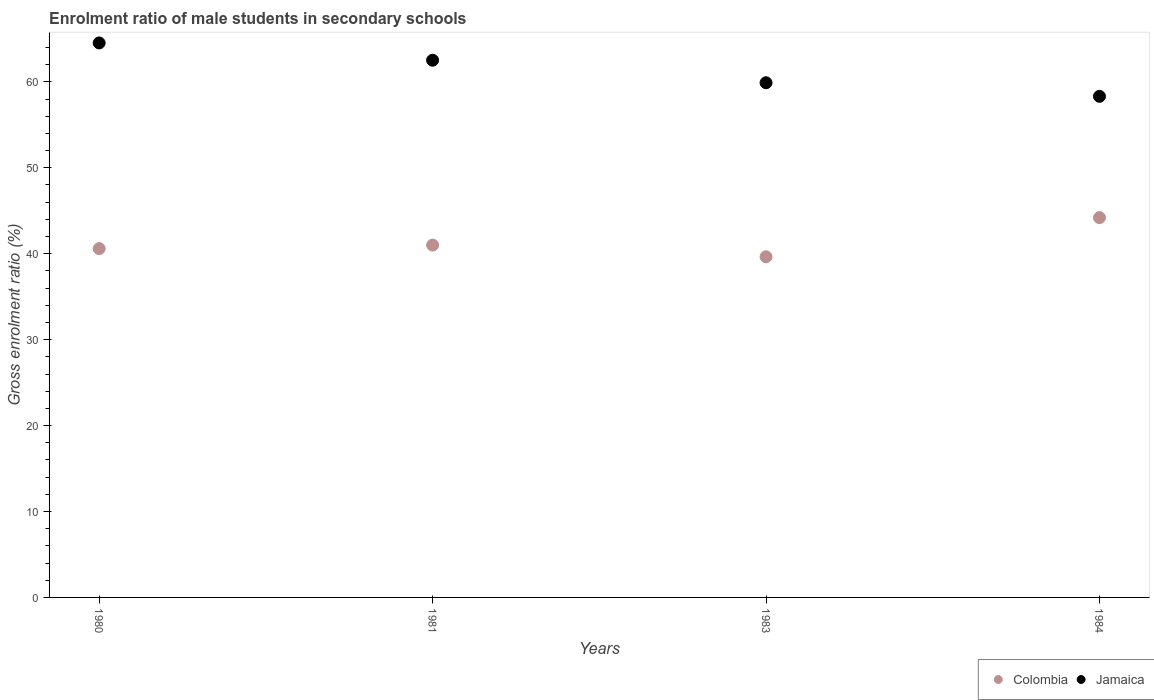How many different coloured dotlines are there?
Offer a very short reply. 2. What is the enrolment ratio of male students in secondary schools in Jamaica in 1981?
Give a very brief answer. 62.52. Across all years, what is the maximum enrolment ratio of male students in secondary schools in Colombia?
Your response must be concise. 44.2. Across all years, what is the minimum enrolment ratio of male students in secondary schools in Jamaica?
Your response must be concise. 58.32. In which year was the enrolment ratio of male students in secondary schools in Colombia maximum?
Ensure brevity in your answer.  1984. In which year was the enrolment ratio of male students in secondary schools in Jamaica minimum?
Make the answer very short. 1984. What is the total enrolment ratio of male students in secondary schools in Colombia in the graph?
Provide a short and direct response. 165.45. What is the difference between the enrolment ratio of male students in secondary schools in Jamaica in 1981 and that in 1984?
Provide a succinct answer. 4.2. What is the difference between the enrolment ratio of male students in secondary schools in Colombia in 1983 and the enrolment ratio of male students in secondary schools in Jamaica in 1981?
Your answer should be very brief. -22.87. What is the average enrolment ratio of male students in secondary schools in Colombia per year?
Offer a very short reply. 41.36. In the year 1981, what is the difference between the enrolment ratio of male students in secondary schools in Colombia and enrolment ratio of male students in secondary schools in Jamaica?
Offer a terse response. -21.51. In how many years, is the enrolment ratio of male students in secondary schools in Jamaica greater than 36 %?
Make the answer very short. 4. What is the ratio of the enrolment ratio of male students in secondary schools in Colombia in 1981 to that in 1984?
Provide a succinct answer. 0.93. Is the enrolment ratio of male students in secondary schools in Jamaica in 1981 less than that in 1983?
Offer a very short reply. No. Is the difference between the enrolment ratio of male students in secondary schools in Colombia in 1981 and 1984 greater than the difference between the enrolment ratio of male students in secondary schools in Jamaica in 1981 and 1984?
Ensure brevity in your answer.  No. What is the difference between the highest and the second highest enrolment ratio of male students in secondary schools in Jamaica?
Provide a succinct answer. 2.01. What is the difference between the highest and the lowest enrolment ratio of male students in secondary schools in Jamaica?
Ensure brevity in your answer.  6.21. In how many years, is the enrolment ratio of male students in secondary schools in Jamaica greater than the average enrolment ratio of male students in secondary schools in Jamaica taken over all years?
Make the answer very short. 2. Is the sum of the enrolment ratio of male students in secondary schools in Jamaica in 1983 and 1984 greater than the maximum enrolment ratio of male students in secondary schools in Colombia across all years?
Provide a short and direct response. Yes. Does the enrolment ratio of male students in secondary schools in Jamaica monotonically increase over the years?
Give a very brief answer. No. Is the enrolment ratio of male students in secondary schools in Jamaica strictly greater than the enrolment ratio of male students in secondary schools in Colombia over the years?
Provide a short and direct response. Yes. How many dotlines are there?
Give a very brief answer. 2. Does the graph contain any zero values?
Make the answer very short. No. Where does the legend appear in the graph?
Your answer should be compact. Bottom right. What is the title of the graph?
Keep it short and to the point. Enrolment ratio of male students in secondary schools. What is the label or title of the X-axis?
Offer a very short reply. Years. What is the Gross enrolment ratio (%) of Colombia in 1980?
Your answer should be compact. 40.6. What is the Gross enrolment ratio (%) in Jamaica in 1980?
Ensure brevity in your answer.  64.53. What is the Gross enrolment ratio (%) in Colombia in 1981?
Keep it short and to the point. 41.01. What is the Gross enrolment ratio (%) in Jamaica in 1981?
Your answer should be very brief. 62.52. What is the Gross enrolment ratio (%) in Colombia in 1983?
Keep it short and to the point. 39.64. What is the Gross enrolment ratio (%) of Jamaica in 1983?
Make the answer very short. 59.9. What is the Gross enrolment ratio (%) of Colombia in 1984?
Provide a succinct answer. 44.2. What is the Gross enrolment ratio (%) in Jamaica in 1984?
Keep it short and to the point. 58.32. Across all years, what is the maximum Gross enrolment ratio (%) of Colombia?
Provide a succinct answer. 44.2. Across all years, what is the maximum Gross enrolment ratio (%) in Jamaica?
Your answer should be compact. 64.53. Across all years, what is the minimum Gross enrolment ratio (%) of Colombia?
Your answer should be compact. 39.64. Across all years, what is the minimum Gross enrolment ratio (%) of Jamaica?
Provide a short and direct response. 58.32. What is the total Gross enrolment ratio (%) in Colombia in the graph?
Your answer should be compact. 165.45. What is the total Gross enrolment ratio (%) in Jamaica in the graph?
Offer a terse response. 245.26. What is the difference between the Gross enrolment ratio (%) in Colombia in 1980 and that in 1981?
Provide a short and direct response. -0.41. What is the difference between the Gross enrolment ratio (%) in Jamaica in 1980 and that in 1981?
Your answer should be very brief. 2.01. What is the difference between the Gross enrolment ratio (%) in Colombia in 1980 and that in 1983?
Ensure brevity in your answer.  0.95. What is the difference between the Gross enrolment ratio (%) of Jamaica in 1980 and that in 1983?
Your response must be concise. 4.63. What is the difference between the Gross enrolment ratio (%) in Colombia in 1980 and that in 1984?
Your response must be concise. -3.6. What is the difference between the Gross enrolment ratio (%) of Jamaica in 1980 and that in 1984?
Keep it short and to the point. 6.21. What is the difference between the Gross enrolment ratio (%) in Colombia in 1981 and that in 1983?
Give a very brief answer. 1.36. What is the difference between the Gross enrolment ratio (%) in Jamaica in 1981 and that in 1983?
Offer a very short reply. 2.62. What is the difference between the Gross enrolment ratio (%) in Colombia in 1981 and that in 1984?
Offer a very short reply. -3.19. What is the difference between the Gross enrolment ratio (%) of Jamaica in 1981 and that in 1984?
Provide a short and direct response. 4.2. What is the difference between the Gross enrolment ratio (%) in Colombia in 1983 and that in 1984?
Your response must be concise. -4.56. What is the difference between the Gross enrolment ratio (%) of Jamaica in 1983 and that in 1984?
Keep it short and to the point. 1.58. What is the difference between the Gross enrolment ratio (%) in Colombia in 1980 and the Gross enrolment ratio (%) in Jamaica in 1981?
Your answer should be compact. -21.92. What is the difference between the Gross enrolment ratio (%) in Colombia in 1980 and the Gross enrolment ratio (%) in Jamaica in 1983?
Your response must be concise. -19.3. What is the difference between the Gross enrolment ratio (%) of Colombia in 1980 and the Gross enrolment ratio (%) of Jamaica in 1984?
Offer a terse response. -17.72. What is the difference between the Gross enrolment ratio (%) in Colombia in 1981 and the Gross enrolment ratio (%) in Jamaica in 1983?
Provide a succinct answer. -18.89. What is the difference between the Gross enrolment ratio (%) of Colombia in 1981 and the Gross enrolment ratio (%) of Jamaica in 1984?
Your answer should be very brief. -17.31. What is the difference between the Gross enrolment ratio (%) in Colombia in 1983 and the Gross enrolment ratio (%) in Jamaica in 1984?
Give a very brief answer. -18.67. What is the average Gross enrolment ratio (%) in Colombia per year?
Make the answer very short. 41.36. What is the average Gross enrolment ratio (%) in Jamaica per year?
Your answer should be very brief. 61.32. In the year 1980, what is the difference between the Gross enrolment ratio (%) in Colombia and Gross enrolment ratio (%) in Jamaica?
Ensure brevity in your answer.  -23.93. In the year 1981, what is the difference between the Gross enrolment ratio (%) of Colombia and Gross enrolment ratio (%) of Jamaica?
Give a very brief answer. -21.51. In the year 1983, what is the difference between the Gross enrolment ratio (%) in Colombia and Gross enrolment ratio (%) in Jamaica?
Offer a very short reply. -20.25. In the year 1984, what is the difference between the Gross enrolment ratio (%) of Colombia and Gross enrolment ratio (%) of Jamaica?
Your answer should be compact. -14.12. What is the ratio of the Gross enrolment ratio (%) in Jamaica in 1980 to that in 1981?
Keep it short and to the point. 1.03. What is the ratio of the Gross enrolment ratio (%) in Colombia in 1980 to that in 1983?
Ensure brevity in your answer.  1.02. What is the ratio of the Gross enrolment ratio (%) in Jamaica in 1980 to that in 1983?
Offer a very short reply. 1.08. What is the ratio of the Gross enrolment ratio (%) in Colombia in 1980 to that in 1984?
Your answer should be compact. 0.92. What is the ratio of the Gross enrolment ratio (%) in Jamaica in 1980 to that in 1984?
Offer a very short reply. 1.11. What is the ratio of the Gross enrolment ratio (%) of Colombia in 1981 to that in 1983?
Offer a very short reply. 1.03. What is the ratio of the Gross enrolment ratio (%) of Jamaica in 1981 to that in 1983?
Your answer should be very brief. 1.04. What is the ratio of the Gross enrolment ratio (%) of Colombia in 1981 to that in 1984?
Give a very brief answer. 0.93. What is the ratio of the Gross enrolment ratio (%) in Jamaica in 1981 to that in 1984?
Your response must be concise. 1.07. What is the ratio of the Gross enrolment ratio (%) of Colombia in 1983 to that in 1984?
Offer a terse response. 0.9. What is the ratio of the Gross enrolment ratio (%) of Jamaica in 1983 to that in 1984?
Offer a terse response. 1.03. What is the difference between the highest and the second highest Gross enrolment ratio (%) in Colombia?
Keep it short and to the point. 3.19. What is the difference between the highest and the second highest Gross enrolment ratio (%) in Jamaica?
Offer a very short reply. 2.01. What is the difference between the highest and the lowest Gross enrolment ratio (%) of Colombia?
Your response must be concise. 4.56. What is the difference between the highest and the lowest Gross enrolment ratio (%) in Jamaica?
Offer a terse response. 6.21. 